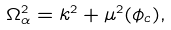Convert formula to latex. <formula><loc_0><loc_0><loc_500><loc_500>\Omega _ { \alpha } ^ { 2 } = k ^ { 2 } + \mu ^ { 2 } ( \phi _ { c } ) ,</formula> 